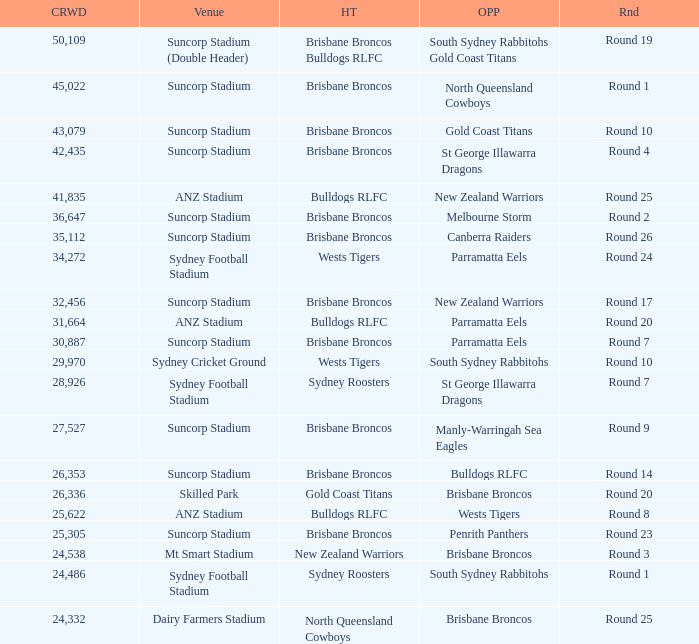What was the attendance at Round 9? 1.0. Give me the full table as a dictionary. {'header': ['CRWD', 'Venue', 'HT', 'OPP', 'Rnd'], 'rows': [['50,109', 'Suncorp Stadium (Double Header)', 'Brisbane Broncos Bulldogs RLFC', 'South Sydney Rabbitohs Gold Coast Titans', 'Round 19'], ['45,022', 'Suncorp Stadium', 'Brisbane Broncos', 'North Queensland Cowboys', 'Round 1'], ['43,079', 'Suncorp Stadium', 'Brisbane Broncos', 'Gold Coast Titans', 'Round 10'], ['42,435', 'Suncorp Stadium', 'Brisbane Broncos', 'St George Illawarra Dragons', 'Round 4'], ['41,835', 'ANZ Stadium', 'Bulldogs RLFC', 'New Zealand Warriors', 'Round 25'], ['36,647', 'Suncorp Stadium', 'Brisbane Broncos', 'Melbourne Storm', 'Round 2'], ['35,112', 'Suncorp Stadium', 'Brisbane Broncos', 'Canberra Raiders', 'Round 26'], ['34,272', 'Sydney Football Stadium', 'Wests Tigers', 'Parramatta Eels', 'Round 24'], ['32,456', 'Suncorp Stadium', 'Brisbane Broncos', 'New Zealand Warriors', 'Round 17'], ['31,664', 'ANZ Stadium', 'Bulldogs RLFC', 'Parramatta Eels', 'Round 20'], ['30,887', 'Suncorp Stadium', 'Brisbane Broncos', 'Parramatta Eels', 'Round 7'], ['29,970', 'Sydney Cricket Ground', 'Wests Tigers', 'South Sydney Rabbitohs', 'Round 10'], ['28,926', 'Sydney Football Stadium', 'Sydney Roosters', 'St George Illawarra Dragons', 'Round 7'], ['27,527', 'Suncorp Stadium', 'Brisbane Broncos', 'Manly-Warringah Sea Eagles', 'Round 9'], ['26,353', 'Suncorp Stadium', 'Brisbane Broncos', 'Bulldogs RLFC', 'Round 14'], ['26,336', 'Skilled Park', 'Gold Coast Titans', 'Brisbane Broncos', 'Round 20'], ['25,622', 'ANZ Stadium', 'Bulldogs RLFC', 'Wests Tigers', 'Round 8'], ['25,305', 'Suncorp Stadium', 'Brisbane Broncos', 'Penrith Panthers', 'Round 23'], ['24,538', 'Mt Smart Stadium', 'New Zealand Warriors', 'Brisbane Broncos', 'Round 3'], ['24,486', 'Sydney Football Stadium', 'Sydney Roosters', 'South Sydney Rabbitohs', 'Round 1'], ['24,332', 'Dairy Farmers Stadium', 'North Queensland Cowboys', 'Brisbane Broncos', 'Round 25']]} 